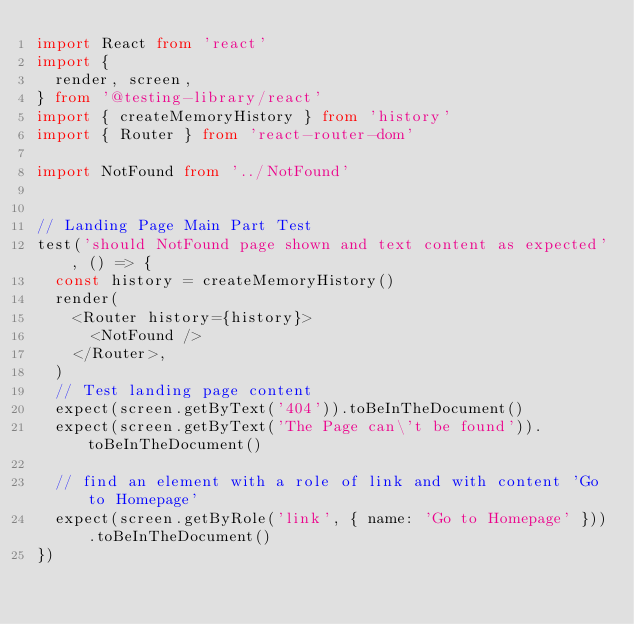Convert code to text. <code><loc_0><loc_0><loc_500><loc_500><_TypeScript_>import React from 'react'
import {
  render, screen,
} from '@testing-library/react'
import { createMemoryHistory } from 'history'
import { Router } from 'react-router-dom'

import NotFound from '../NotFound'


// Landing Page Main Part Test
test('should NotFound page shown and text content as expected', () => {
  const history = createMemoryHistory()
  render(
    <Router history={history}>
      <NotFound />
    </Router>,
  )
  // Test landing page content
  expect(screen.getByText('404')).toBeInTheDocument()
  expect(screen.getByText('The Page can\'t be found')).toBeInTheDocument()

  // find an element with a role of link and with content 'Go to Homepage'
  expect(screen.getByRole('link', { name: 'Go to Homepage' })).toBeInTheDocument()
})
</code> 